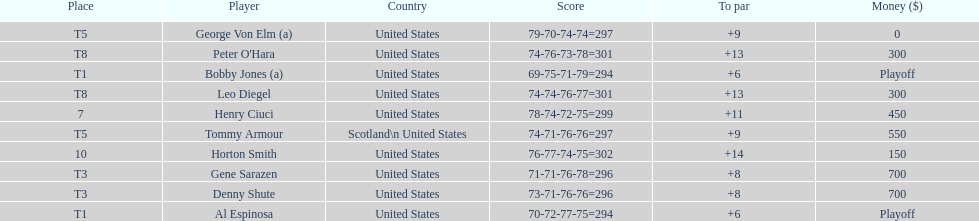Who finished next after bobby jones and al espinosa? Gene Sarazen, Denny Shute. 